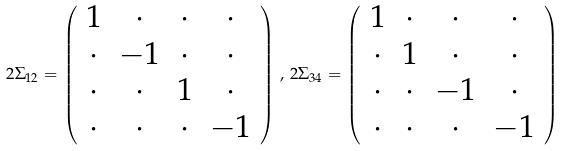<formula> <loc_0><loc_0><loc_500><loc_500>2 \Sigma _ { 1 2 } = \left ( \begin{array} { c c c c } 1 & \cdot & \cdot & \cdot \\ \cdot & - 1 & \cdot & \cdot \\ \cdot & \cdot & 1 & \cdot \\ \cdot & \cdot & \cdot & - 1 \end{array} \right ) \, , \, 2 \Sigma _ { 3 4 } = \left ( \begin{array} { c c c c } 1 & \cdot & \cdot & \cdot \\ \cdot & 1 & \cdot & \cdot \\ \cdot & \cdot & - 1 & \cdot \\ \cdot & \cdot & \cdot & - 1 \end{array} \right )</formula> 